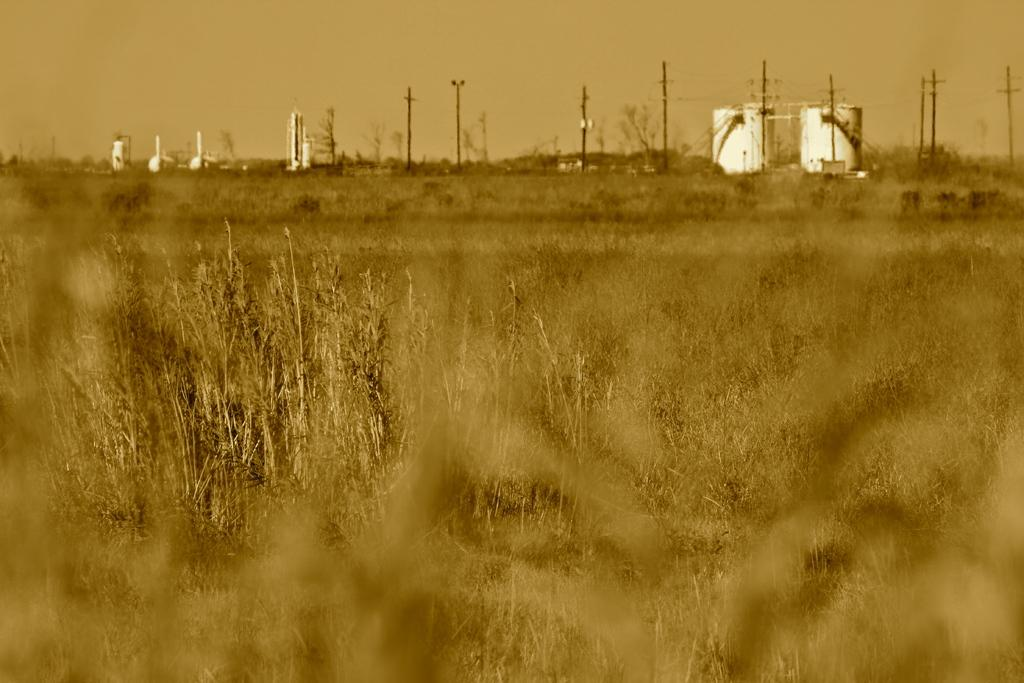What type of vegetation can be seen in the image? There are plants in the image. What can be seen in the background of the image? There are trees, poles, and the sky visible in the background of the image. What else is present in the background of the image? There are other objects in the background of the image. What type of leather is visible on the plants in the image? There is no leather present on the plants in the image; they are made of vegetation. 